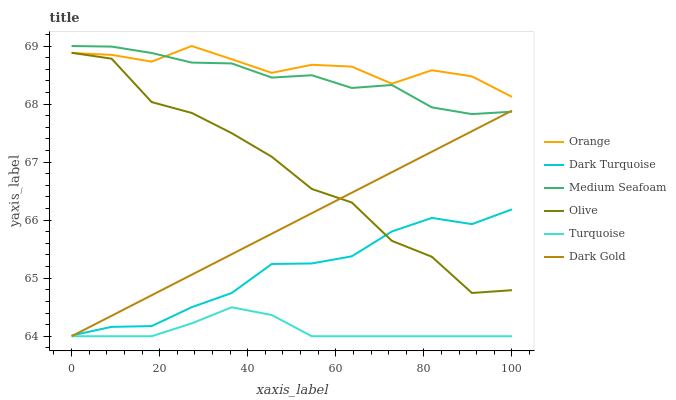Does Turquoise have the minimum area under the curve?
Answer yes or no. Yes. Does Orange have the maximum area under the curve?
Answer yes or no. Yes. Does Dark Gold have the minimum area under the curve?
Answer yes or no. No. Does Dark Gold have the maximum area under the curve?
Answer yes or no. No. Is Dark Gold the smoothest?
Answer yes or no. Yes. Is Olive the roughest?
Answer yes or no. Yes. Is Dark Turquoise the smoothest?
Answer yes or no. No. Is Dark Turquoise the roughest?
Answer yes or no. No. Does Turquoise have the lowest value?
Answer yes or no. Yes. Does Dark Turquoise have the lowest value?
Answer yes or no. No. Does Medium Seafoam have the highest value?
Answer yes or no. Yes. Does Dark Gold have the highest value?
Answer yes or no. No. Is Turquoise less than Dark Turquoise?
Answer yes or no. Yes. Is Medium Seafoam greater than Olive?
Answer yes or no. Yes. Does Medium Seafoam intersect Orange?
Answer yes or no. Yes. Is Medium Seafoam less than Orange?
Answer yes or no. No. Is Medium Seafoam greater than Orange?
Answer yes or no. No. Does Turquoise intersect Dark Turquoise?
Answer yes or no. No. 